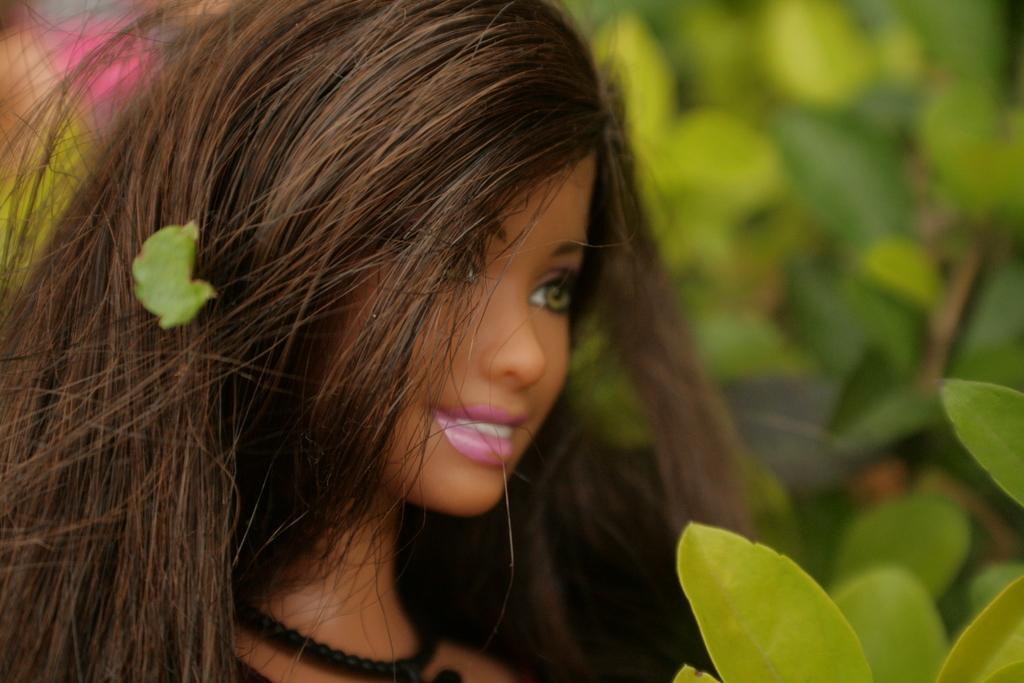What is the main subject of the picture? There is a doll in the picture. What else can be seen in the picture besides the doll? There are leaves in the picture. Can you describe the background of the picture? The background of the picture is blurred. How many legs does the creature have in the picture? There is no creature present in the picture, so it is not possible to determine the number of legs it might have. 